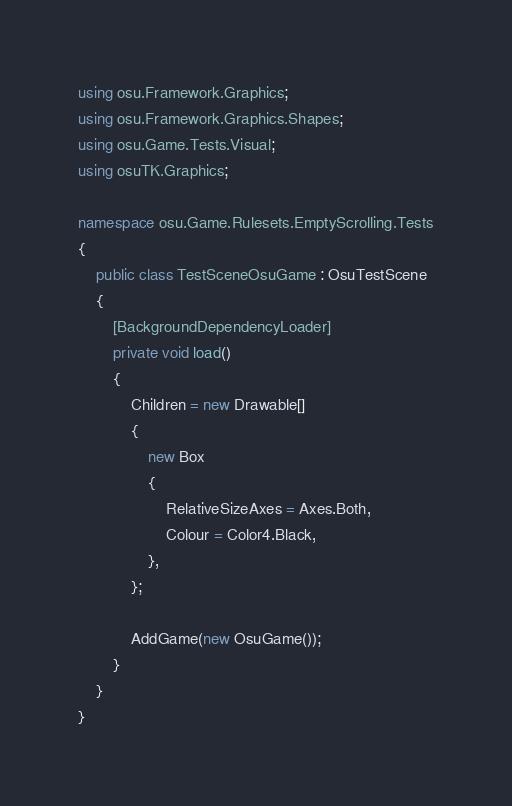Convert code to text. <code><loc_0><loc_0><loc_500><loc_500><_C#_>using osu.Framework.Graphics;
using osu.Framework.Graphics.Shapes;
using osu.Game.Tests.Visual;
using osuTK.Graphics;

namespace osu.Game.Rulesets.EmptyScrolling.Tests
{
    public class TestSceneOsuGame : OsuTestScene
    {
        [BackgroundDependencyLoader]
        private void load()
        {
            Children = new Drawable[]
            {
                new Box
                {
                    RelativeSizeAxes = Axes.Both,
                    Colour = Color4.Black,
                },
            };

            AddGame(new OsuGame());
        }
    }
}
</code> 